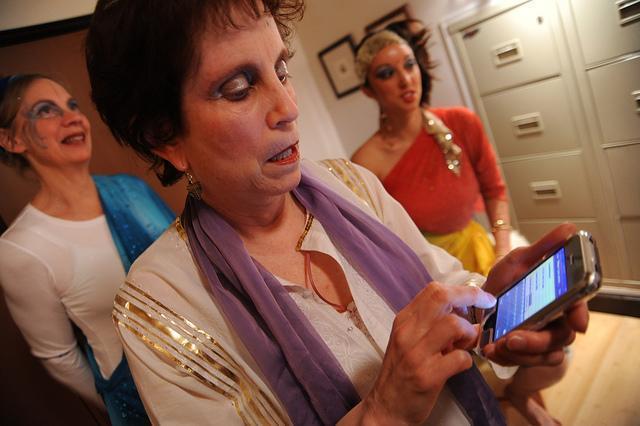How many women do you see?
Give a very brief answer. 3. How many people can you see?
Give a very brief answer. 3. How many microwaves are in the kitchen?
Give a very brief answer. 0. 